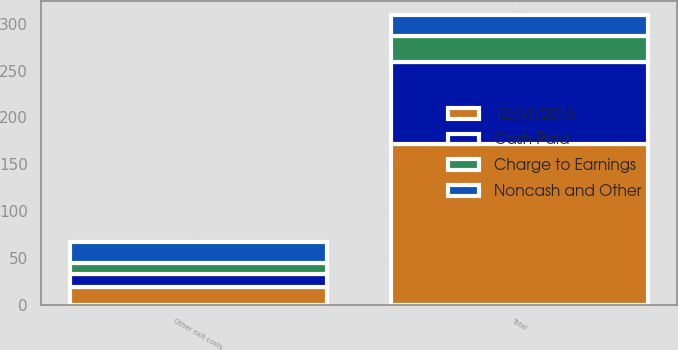Convert chart. <chart><loc_0><loc_0><loc_500><loc_500><stacked_bar_chart><ecel><fcel>Other exit costs<fcel>Total<nl><fcel>Cash Paid<fcel>14<fcel>87<nl><fcel>Noncash and Other<fcel>22<fcel>22<nl><fcel>12/31/2016<fcel>19<fcel>172<nl><fcel>Charge to Earnings<fcel>12<fcel>28<nl></chart> 